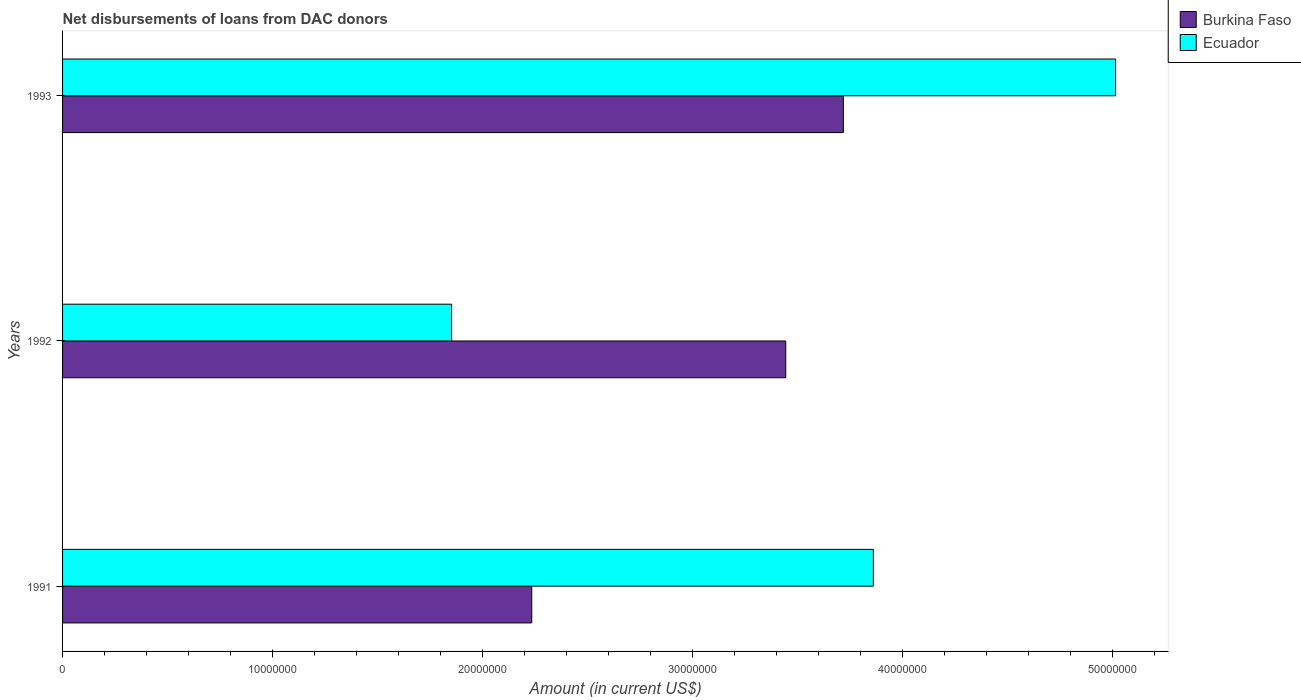Are the number of bars on each tick of the Y-axis equal?
Your answer should be very brief. Yes. How many bars are there on the 1st tick from the bottom?
Provide a short and direct response. 2. In how many cases, is the number of bars for a given year not equal to the number of legend labels?
Give a very brief answer. 0. What is the amount of loans disbursed in Ecuador in 1992?
Your response must be concise. 1.85e+07. Across all years, what is the maximum amount of loans disbursed in Ecuador?
Provide a short and direct response. 5.02e+07. Across all years, what is the minimum amount of loans disbursed in Burkina Faso?
Offer a terse response. 2.23e+07. In which year was the amount of loans disbursed in Ecuador maximum?
Give a very brief answer. 1993. In which year was the amount of loans disbursed in Burkina Faso minimum?
Offer a terse response. 1991. What is the total amount of loans disbursed in Burkina Faso in the graph?
Provide a short and direct response. 9.40e+07. What is the difference between the amount of loans disbursed in Burkina Faso in 1991 and that in 1992?
Provide a short and direct response. -1.21e+07. What is the difference between the amount of loans disbursed in Burkina Faso in 1993 and the amount of loans disbursed in Ecuador in 1992?
Make the answer very short. 1.87e+07. What is the average amount of loans disbursed in Ecuador per year?
Provide a succinct answer. 3.58e+07. In the year 1991, what is the difference between the amount of loans disbursed in Burkina Faso and amount of loans disbursed in Ecuador?
Give a very brief answer. -1.63e+07. In how many years, is the amount of loans disbursed in Burkina Faso greater than 10000000 US$?
Your answer should be compact. 3. What is the ratio of the amount of loans disbursed in Burkina Faso in 1991 to that in 1993?
Give a very brief answer. 0.6. Is the difference between the amount of loans disbursed in Burkina Faso in 1991 and 1992 greater than the difference between the amount of loans disbursed in Ecuador in 1991 and 1992?
Offer a very short reply. No. What is the difference between the highest and the second highest amount of loans disbursed in Ecuador?
Make the answer very short. 1.15e+07. What is the difference between the highest and the lowest amount of loans disbursed in Ecuador?
Your answer should be compact. 3.16e+07. Is the sum of the amount of loans disbursed in Burkina Faso in 1992 and 1993 greater than the maximum amount of loans disbursed in Ecuador across all years?
Provide a short and direct response. Yes. What does the 1st bar from the top in 1991 represents?
Provide a short and direct response. Ecuador. What does the 1st bar from the bottom in 1993 represents?
Your answer should be compact. Burkina Faso. How many bars are there?
Offer a very short reply. 6. Are all the bars in the graph horizontal?
Your answer should be very brief. Yes. How many years are there in the graph?
Provide a short and direct response. 3. What is the difference between two consecutive major ticks on the X-axis?
Give a very brief answer. 1.00e+07. Are the values on the major ticks of X-axis written in scientific E-notation?
Offer a terse response. No. Does the graph contain any zero values?
Make the answer very short. No. Does the graph contain grids?
Your answer should be very brief. No. How many legend labels are there?
Ensure brevity in your answer.  2. What is the title of the graph?
Make the answer very short. Net disbursements of loans from DAC donors. Does "Mongolia" appear as one of the legend labels in the graph?
Provide a short and direct response. No. What is the Amount (in current US$) in Burkina Faso in 1991?
Give a very brief answer. 2.23e+07. What is the Amount (in current US$) in Ecuador in 1991?
Your answer should be very brief. 3.86e+07. What is the Amount (in current US$) of Burkina Faso in 1992?
Give a very brief answer. 3.44e+07. What is the Amount (in current US$) of Ecuador in 1992?
Make the answer very short. 1.85e+07. What is the Amount (in current US$) of Burkina Faso in 1993?
Provide a short and direct response. 3.72e+07. What is the Amount (in current US$) of Ecuador in 1993?
Offer a terse response. 5.02e+07. Across all years, what is the maximum Amount (in current US$) of Burkina Faso?
Provide a succinct answer. 3.72e+07. Across all years, what is the maximum Amount (in current US$) in Ecuador?
Your answer should be compact. 5.02e+07. Across all years, what is the minimum Amount (in current US$) in Burkina Faso?
Give a very brief answer. 2.23e+07. Across all years, what is the minimum Amount (in current US$) of Ecuador?
Make the answer very short. 1.85e+07. What is the total Amount (in current US$) of Burkina Faso in the graph?
Ensure brevity in your answer.  9.40e+07. What is the total Amount (in current US$) in Ecuador in the graph?
Ensure brevity in your answer.  1.07e+08. What is the difference between the Amount (in current US$) of Burkina Faso in 1991 and that in 1992?
Your response must be concise. -1.21e+07. What is the difference between the Amount (in current US$) in Ecuador in 1991 and that in 1992?
Your response must be concise. 2.01e+07. What is the difference between the Amount (in current US$) of Burkina Faso in 1991 and that in 1993?
Provide a short and direct response. -1.48e+07. What is the difference between the Amount (in current US$) of Ecuador in 1991 and that in 1993?
Offer a very short reply. -1.15e+07. What is the difference between the Amount (in current US$) of Burkina Faso in 1992 and that in 1993?
Provide a succinct answer. -2.74e+06. What is the difference between the Amount (in current US$) of Ecuador in 1992 and that in 1993?
Offer a terse response. -3.16e+07. What is the difference between the Amount (in current US$) of Burkina Faso in 1991 and the Amount (in current US$) of Ecuador in 1992?
Give a very brief answer. 3.82e+06. What is the difference between the Amount (in current US$) in Burkina Faso in 1991 and the Amount (in current US$) in Ecuador in 1993?
Your answer should be very brief. -2.78e+07. What is the difference between the Amount (in current US$) of Burkina Faso in 1992 and the Amount (in current US$) of Ecuador in 1993?
Offer a terse response. -1.57e+07. What is the average Amount (in current US$) in Burkina Faso per year?
Your response must be concise. 3.13e+07. What is the average Amount (in current US$) in Ecuador per year?
Ensure brevity in your answer.  3.58e+07. In the year 1991, what is the difference between the Amount (in current US$) in Burkina Faso and Amount (in current US$) in Ecuador?
Your response must be concise. -1.63e+07. In the year 1992, what is the difference between the Amount (in current US$) in Burkina Faso and Amount (in current US$) in Ecuador?
Give a very brief answer. 1.59e+07. In the year 1993, what is the difference between the Amount (in current US$) of Burkina Faso and Amount (in current US$) of Ecuador?
Make the answer very short. -1.30e+07. What is the ratio of the Amount (in current US$) of Burkina Faso in 1991 to that in 1992?
Offer a terse response. 0.65. What is the ratio of the Amount (in current US$) of Ecuador in 1991 to that in 1992?
Your answer should be compact. 2.08. What is the ratio of the Amount (in current US$) in Burkina Faso in 1991 to that in 1993?
Provide a succinct answer. 0.6. What is the ratio of the Amount (in current US$) of Ecuador in 1991 to that in 1993?
Offer a terse response. 0.77. What is the ratio of the Amount (in current US$) of Burkina Faso in 1992 to that in 1993?
Offer a terse response. 0.93. What is the ratio of the Amount (in current US$) in Ecuador in 1992 to that in 1993?
Your response must be concise. 0.37. What is the difference between the highest and the second highest Amount (in current US$) of Burkina Faso?
Offer a terse response. 2.74e+06. What is the difference between the highest and the second highest Amount (in current US$) of Ecuador?
Give a very brief answer. 1.15e+07. What is the difference between the highest and the lowest Amount (in current US$) of Burkina Faso?
Keep it short and to the point. 1.48e+07. What is the difference between the highest and the lowest Amount (in current US$) in Ecuador?
Give a very brief answer. 3.16e+07. 